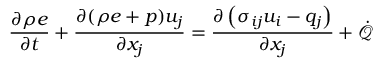<formula> <loc_0><loc_0><loc_500><loc_500>\frac { \partial \rho e } { \partial t } + \frac { \partial ( \rho e + p ) u _ { j } } { \partial x _ { j } } = \frac { \partial \left ( \sigma _ { i j } u _ { i } - q _ { j } \right ) } { \partial x _ { j } } + \dot { \mathcal { Q } }</formula> 